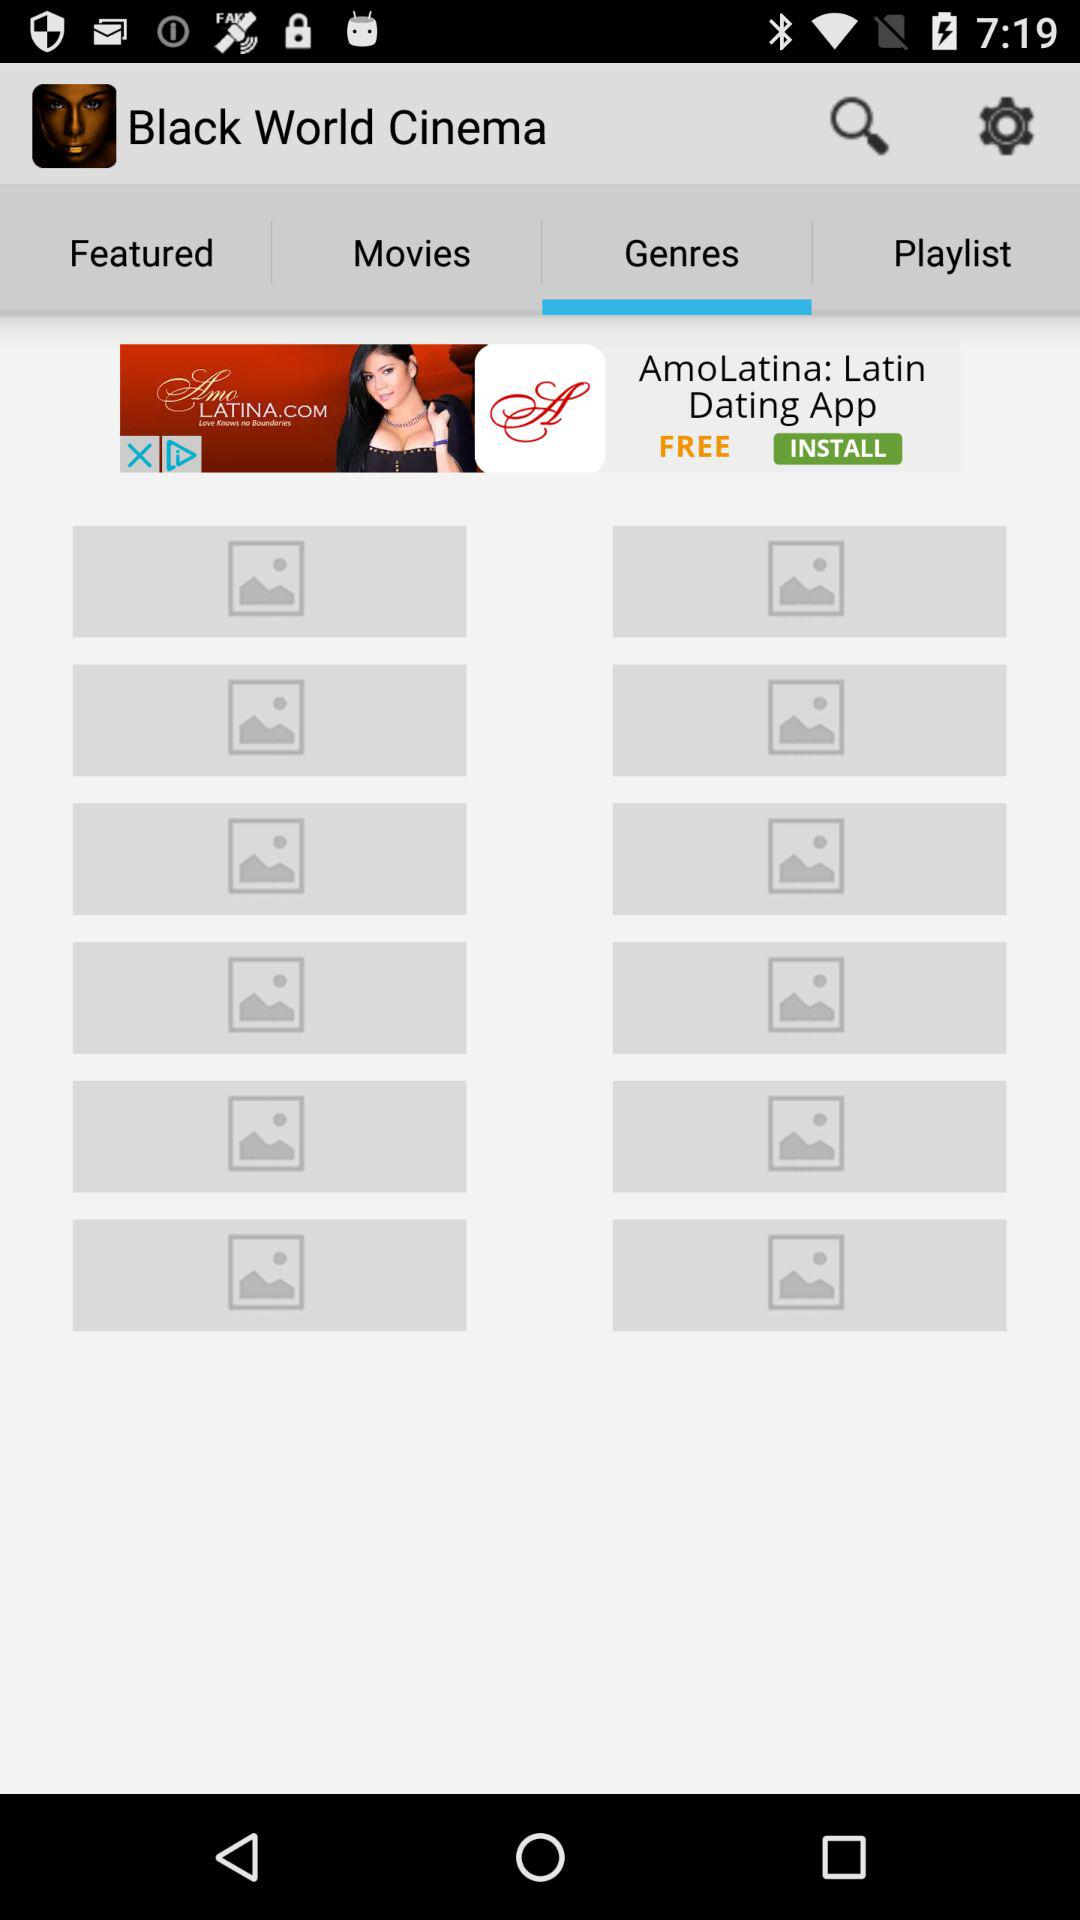Which tab is selected? The selected tab is "Genres". 